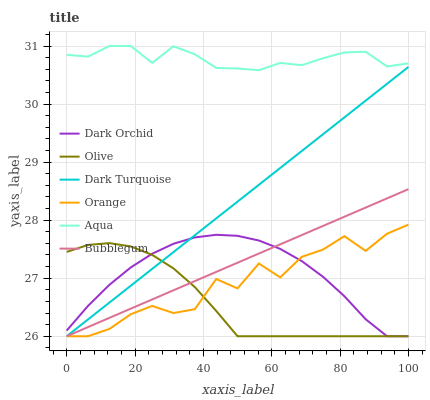Does Bubblegum have the minimum area under the curve?
Answer yes or no. No. Does Bubblegum have the maximum area under the curve?
Answer yes or no. No. Is Aqua the smoothest?
Answer yes or no. No. Is Aqua the roughest?
Answer yes or no. No. Does Aqua have the lowest value?
Answer yes or no. No. Does Bubblegum have the highest value?
Answer yes or no. No. Is Olive less than Aqua?
Answer yes or no. Yes. Is Aqua greater than Dark Turquoise?
Answer yes or no. Yes. Does Olive intersect Aqua?
Answer yes or no. No. 